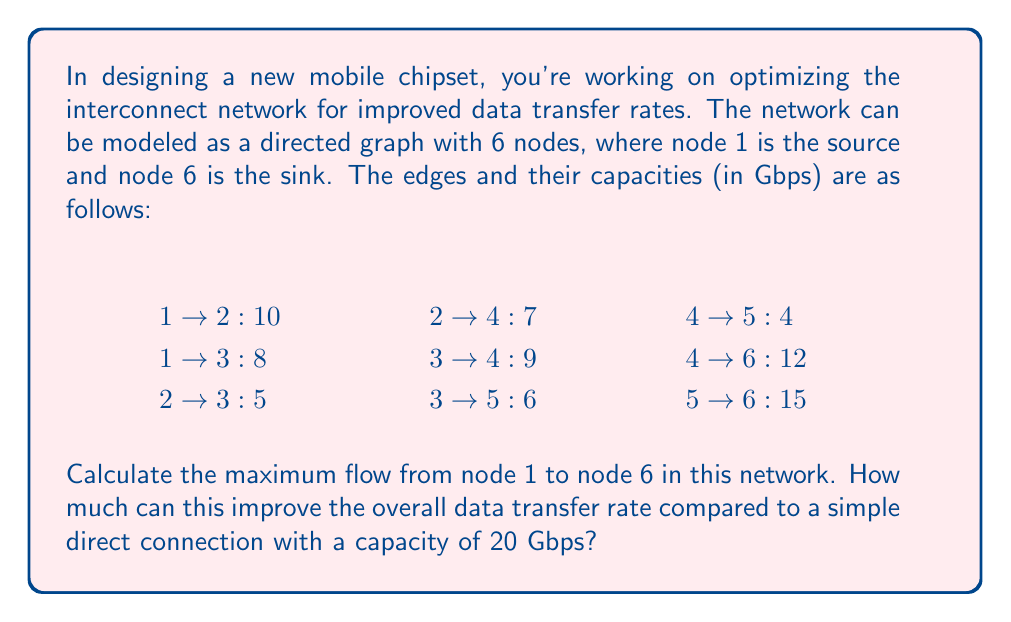Help me with this question. To solve this problem, we'll use the Ford-Fulkerson algorithm to find the maximum flow in the given network. Here's a step-by-step explanation:

1. Initialize the flow to 0 for all edges.

2. Find augmenting paths from source (node 1) to sink (node 6) and augment the flow:

   Path 1: 1 → 2 → 4 → 6
   Bottleneck: min(10, 7, 12) = 7
   New flow: 7

   Path 2: 1 → 3 → 4 → 6
   Bottleneck: min(8, 9, 5) = 5
   New flow: 7 + 5 = 12

   Path 3: 1 → 3 → 5 → 6
   Bottleneck: min(3, 6, 15) = 3
   New flow: 12 + 3 = 15

   Path 4: 1 → 2 → 3 → 5 → 6
   Bottleneck: min(3, 5, 3, 12) = 3
   New flow: 15 + 3 = 18

3. No more augmenting paths exist, so the maximum flow is 18 Gbps.

To calculate the improvement over a simple direct connection:

Improvement = (Maximum flow - Direct connection capacity) / Direct connection capacity * 100%
            = (18 - 20) / 20 * 100%
            = -10%

This means that the interconnect network actually performs 10% worse than a simple direct connection in terms of maximum data transfer rate.
Answer: The maximum flow in the interconnect network is 18 Gbps. Compared to a simple direct connection with a capacity of 20 Gbps, this network performs 10% worse in terms of maximum data transfer rate. 